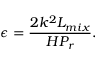Convert formula to latex. <formula><loc_0><loc_0><loc_500><loc_500>\epsilon = \frac { 2 k ^ { 2 } L _ { m i x } } { H P _ { r } } .</formula> 